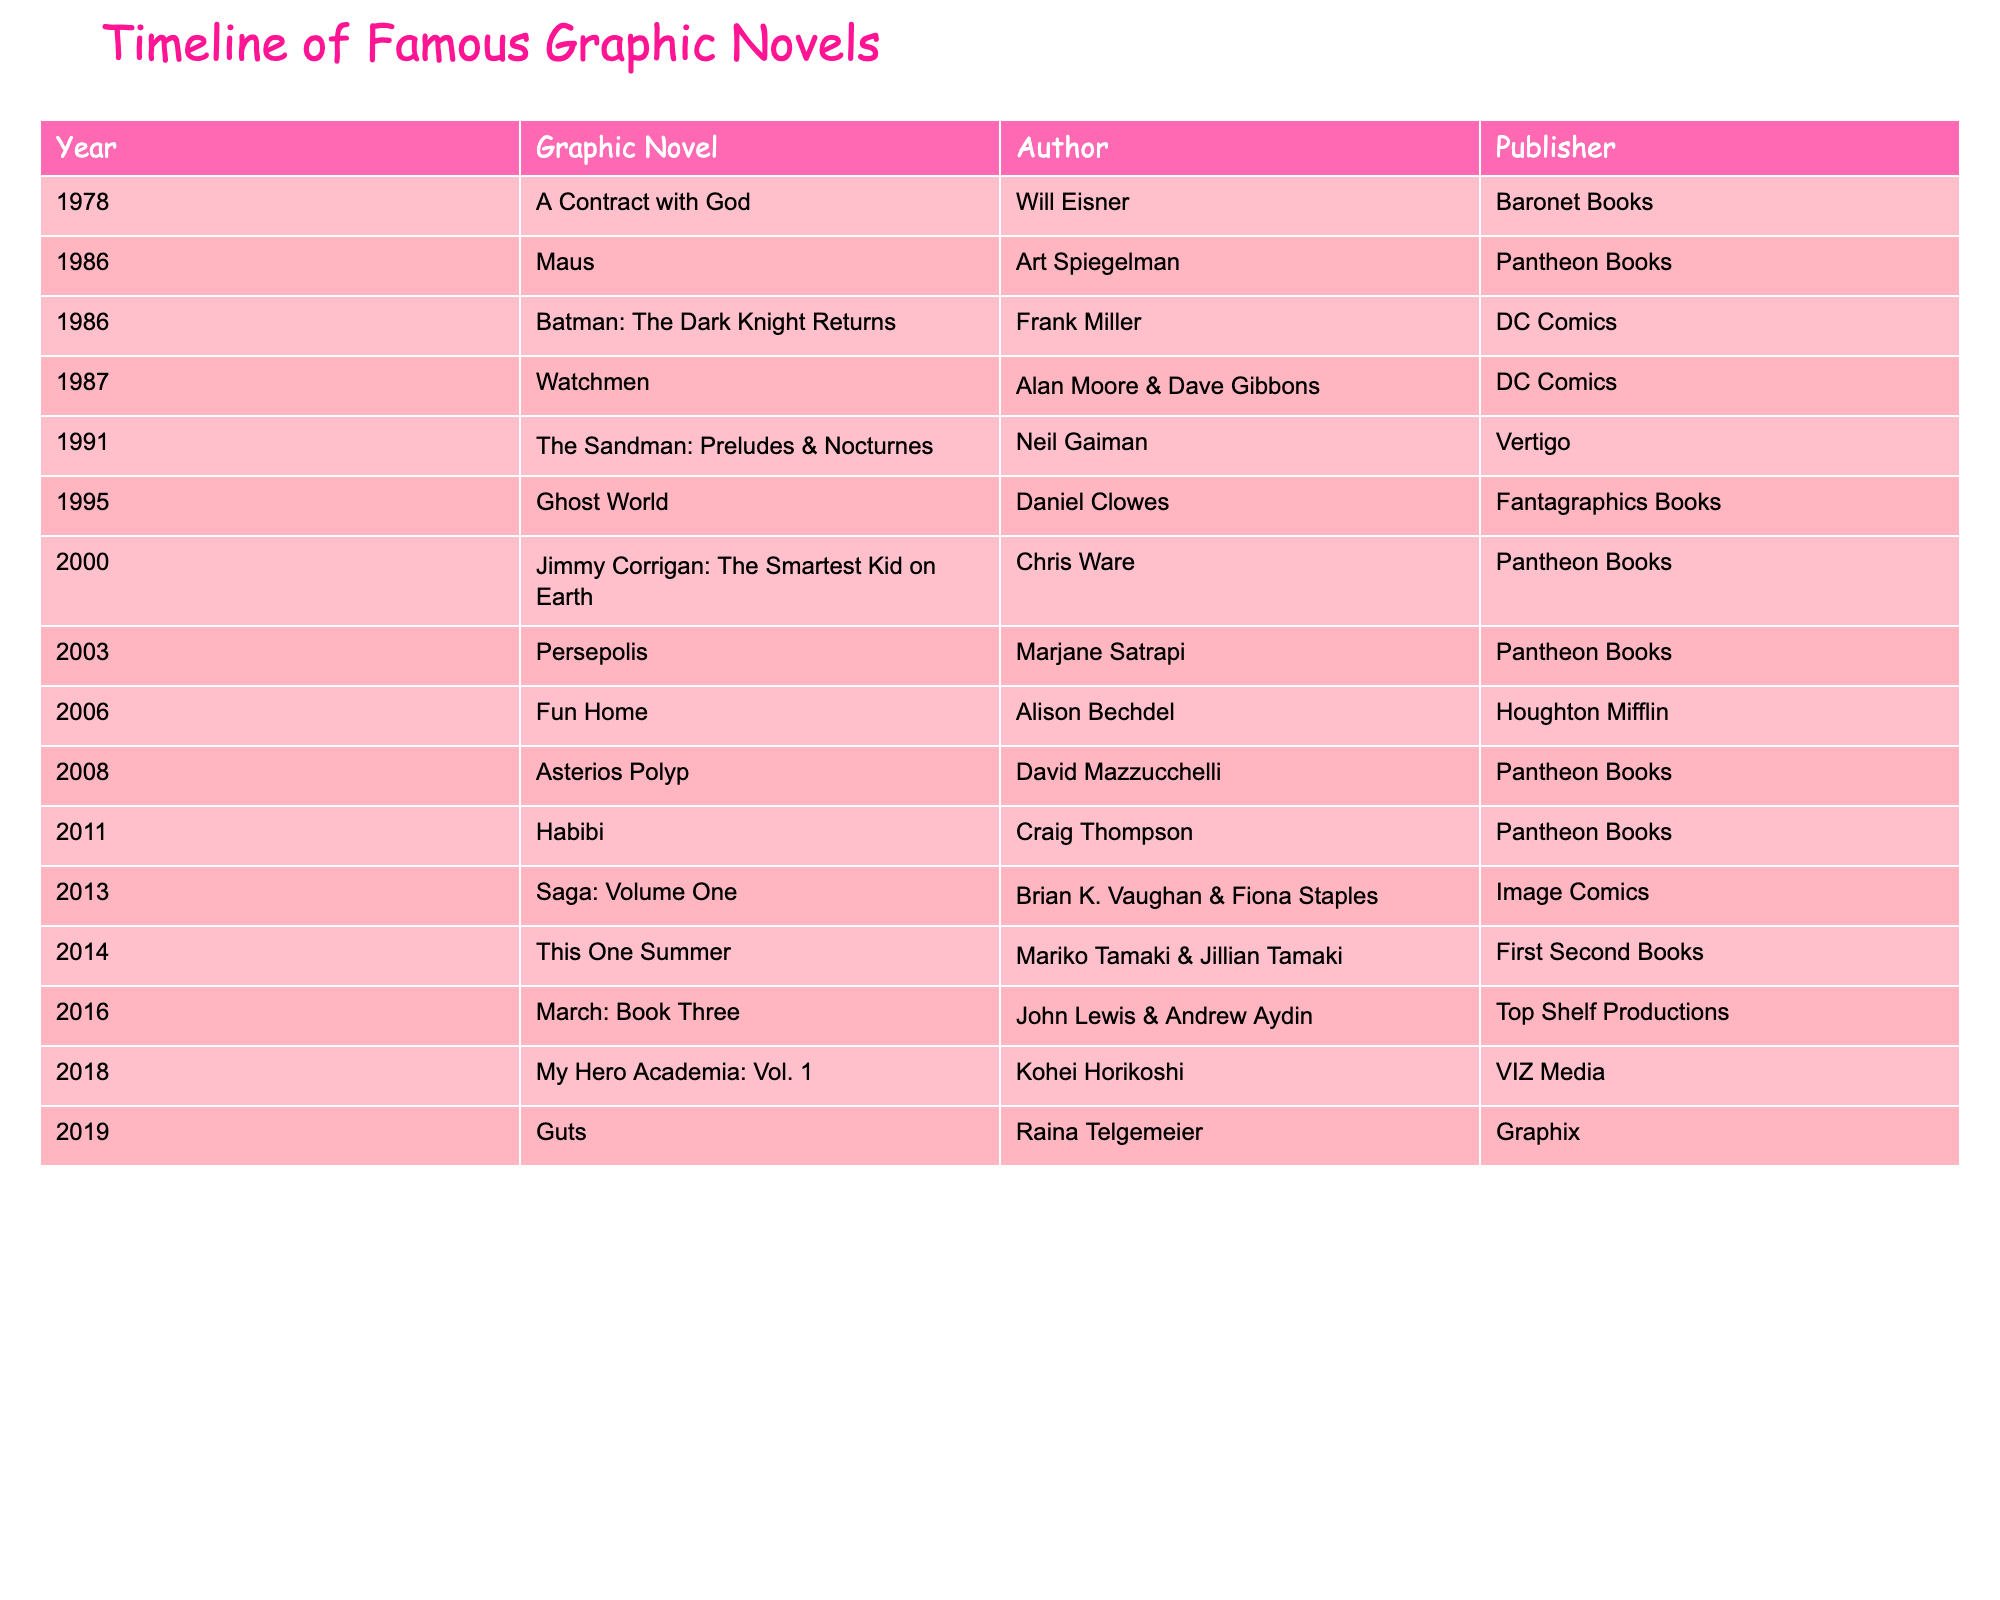What year was "Maus" published? The table lists the graphic novels along with their publication years. Looking at the row for "Maus," it shows the year 1986.
Answer: 1986 Who is the author of "Fun Home"? The table includes a column for authors next to the corresponding graphic novel. For "Fun Home," the author listed is Alison Bechdel.
Answer: Alison Bechdel Which graphic novel was published by VIZ Media? The table indicates that "My Hero Academia: Vol. 1" is associated with the publisher VIZ Media in the publication column.
Answer: My Hero Academia: Vol. 1 How many graphic novels were published in the year 2014? By examining the publication years in the table, only one graphic novel, "This One Summer," is listed under the year 2014.
Answer: 1 What is the earliest publication year among the listed graphic novels? Looking at the publication years in the table, the earliest year mentioned is 1978, which corresponds to "A Contract with God."
Answer: 1978 Is "Saga: Volume One" associated with DC Comics? Checking the publisher column for "Saga: Volume One," it does not list DC Comics but instead shows Image Comics as the publisher.
Answer: No Which graphic novel has the most recent publication date? Scanning the publication dates in the table reveals that "Guts" was published in 2019, which is the most recent date listed among all graphic novels.
Answer: 2019 Which author has the most graphic novels published in this timeline? By counting the occurrences of each author's name in the table, it's noted that the author Chris Ware has one (1) graphic novel, which is tied with several others. Therefore, no single author stands out.
Answer: None stands out What is the difference in years between the publication of "Watchmen" and "Asterios Polyp"? "Watchmen" was published in 1987 and "Asterios Polyp" in 2008. Calculating the difference: 2008 - 1987 = 21 years.
Answer: 21 years 